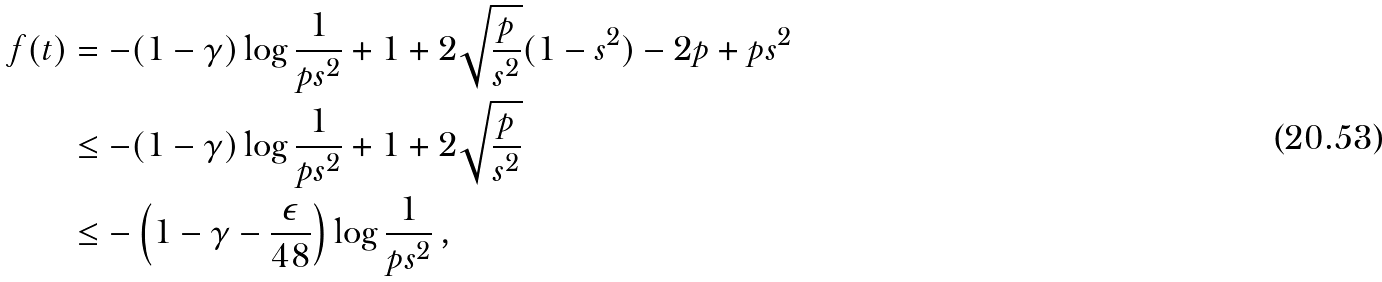<formula> <loc_0><loc_0><loc_500><loc_500>f ( t ) & = - ( 1 - \gamma ) \log \frac { 1 } { p s ^ { 2 } } + 1 + 2 \sqrt { \frac { p } { s ^ { 2 } } } ( 1 - s ^ { 2 } ) - 2 p + p s ^ { 2 } \\ & \leq - ( 1 - \gamma ) \log \frac { 1 } { p s ^ { 2 } } + 1 + 2 \sqrt { \frac { p } { s ^ { 2 } } } \\ & \leq - \left ( 1 - \gamma - \frac { \epsilon } { 4 8 } \right ) \log \frac { 1 } { p s ^ { 2 } } \, ,</formula> 